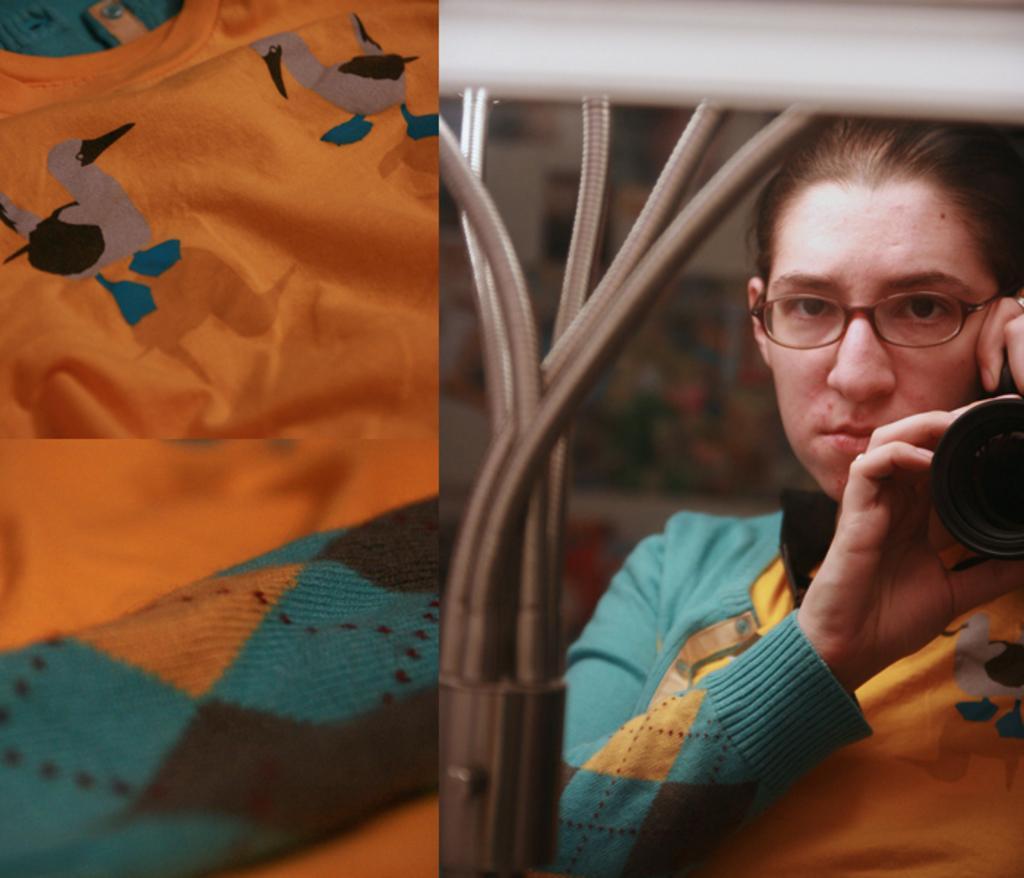In one or two sentences, can you explain what this image depicts? In this image I can see a woman and I can see she is holding a camera. I can also see she is wearing specs and here I can see a cloth. 